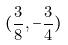<formula> <loc_0><loc_0><loc_500><loc_500>( \frac { 3 } { 8 } , - \frac { 3 } { 4 } )</formula> 